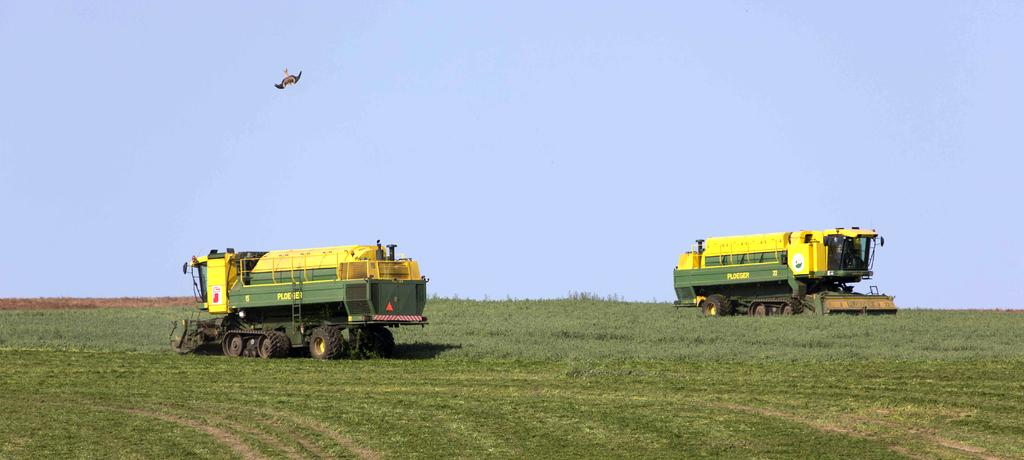What type of vehicles are in the image? There are field vehicles in the image. Where are the vehicles located? The vehicles are on farmland. What can be seen in the top left corner of the image? There is an eagle in the top left of the image. What is visible at the top of the image? The sky is visible at the top of the image. What type of vegetation is at the bottom of the image? There is grass at the bottom of the image. How many fingers are visible on the eagle in the image? There are no fingers visible in the image, as the eagle is a bird and does not have fingers. 